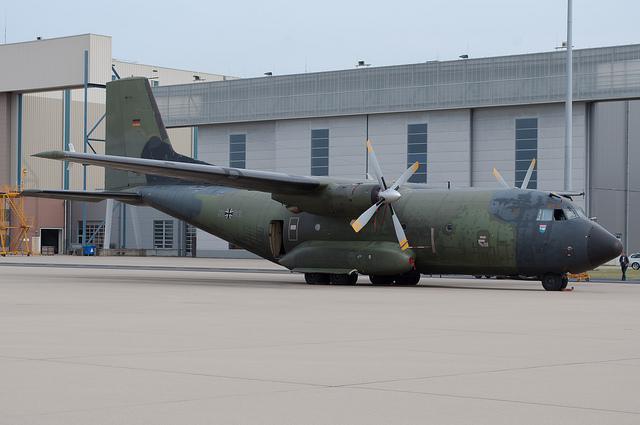Is there more than one plane?
Give a very brief answer. No. What color is the plane?
Concise answer only. Green. How many stripes on each blade of the propeller?
Short answer required. 2. Who owns this plane?
Answer briefly. Germany. What side do the people get on?
Be succinct. Left. How many engines does the plane have?
Give a very brief answer. 2. 